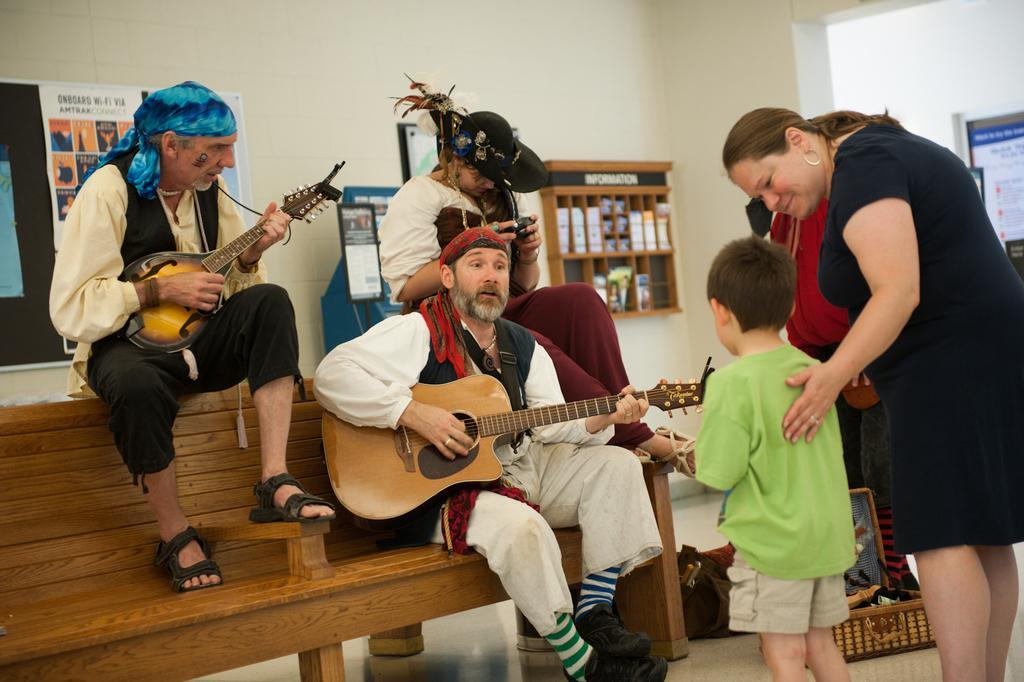Can you describe this image briefly? In this image I see few people and I see that 2 men over here are sitting on the bench and they are with the musical instruments, I can also see that this woman is smiling. In the background I can see the wall, few papers on the notice board and a bag over here. 